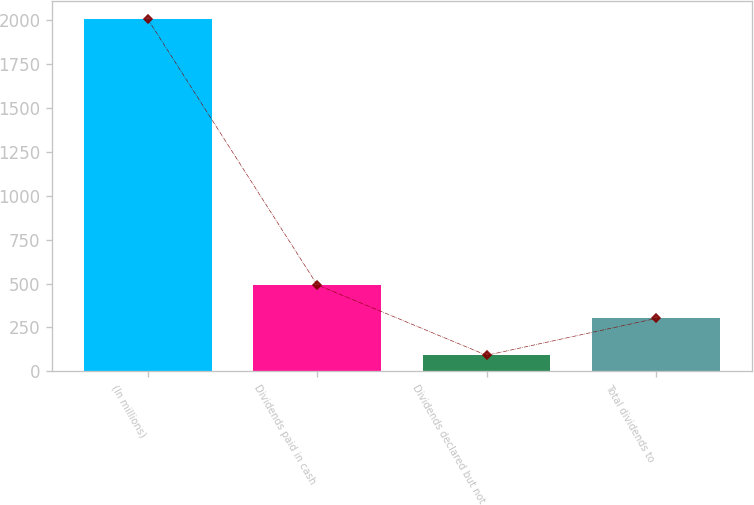Convert chart. <chart><loc_0><loc_0><loc_500><loc_500><bar_chart><fcel>(In millions)<fcel>Dividends paid in cash<fcel>Dividends declared but not<fcel>Total dividends to<nl><fcel>2007<fcel>492.6<fcel>91<fcel>301<nl></chart> 